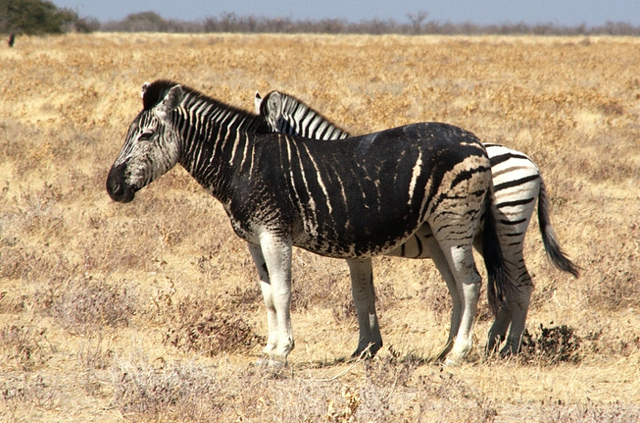<image>What color stripes are missing? I am not sure what color stripes are missing. It can be white or brown. What color stripes are missing? I am not sure which color stripes are missing. It can be either white or brown. 